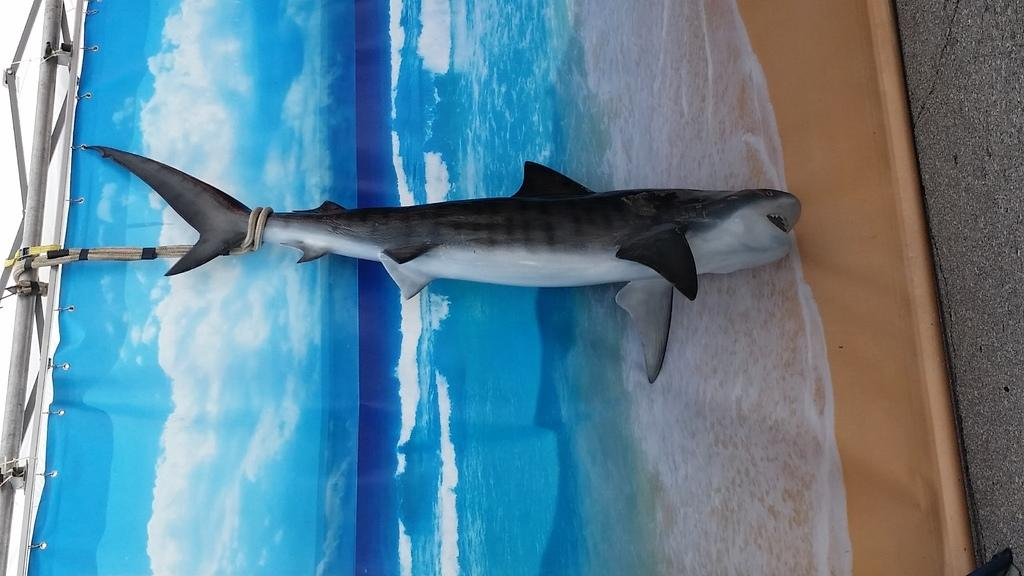What is the main subject of the image? There is a fish in the image. What can be seen in the background of the image? There is a banner in the background of the image. What prints are featured on the banner? The banner has a print of water and a print of the sky. What type of potato is being prepared by the secretary in the image? There is no potato or secretary present in the image; it features a fish and a banner with prints of water and the sky. 